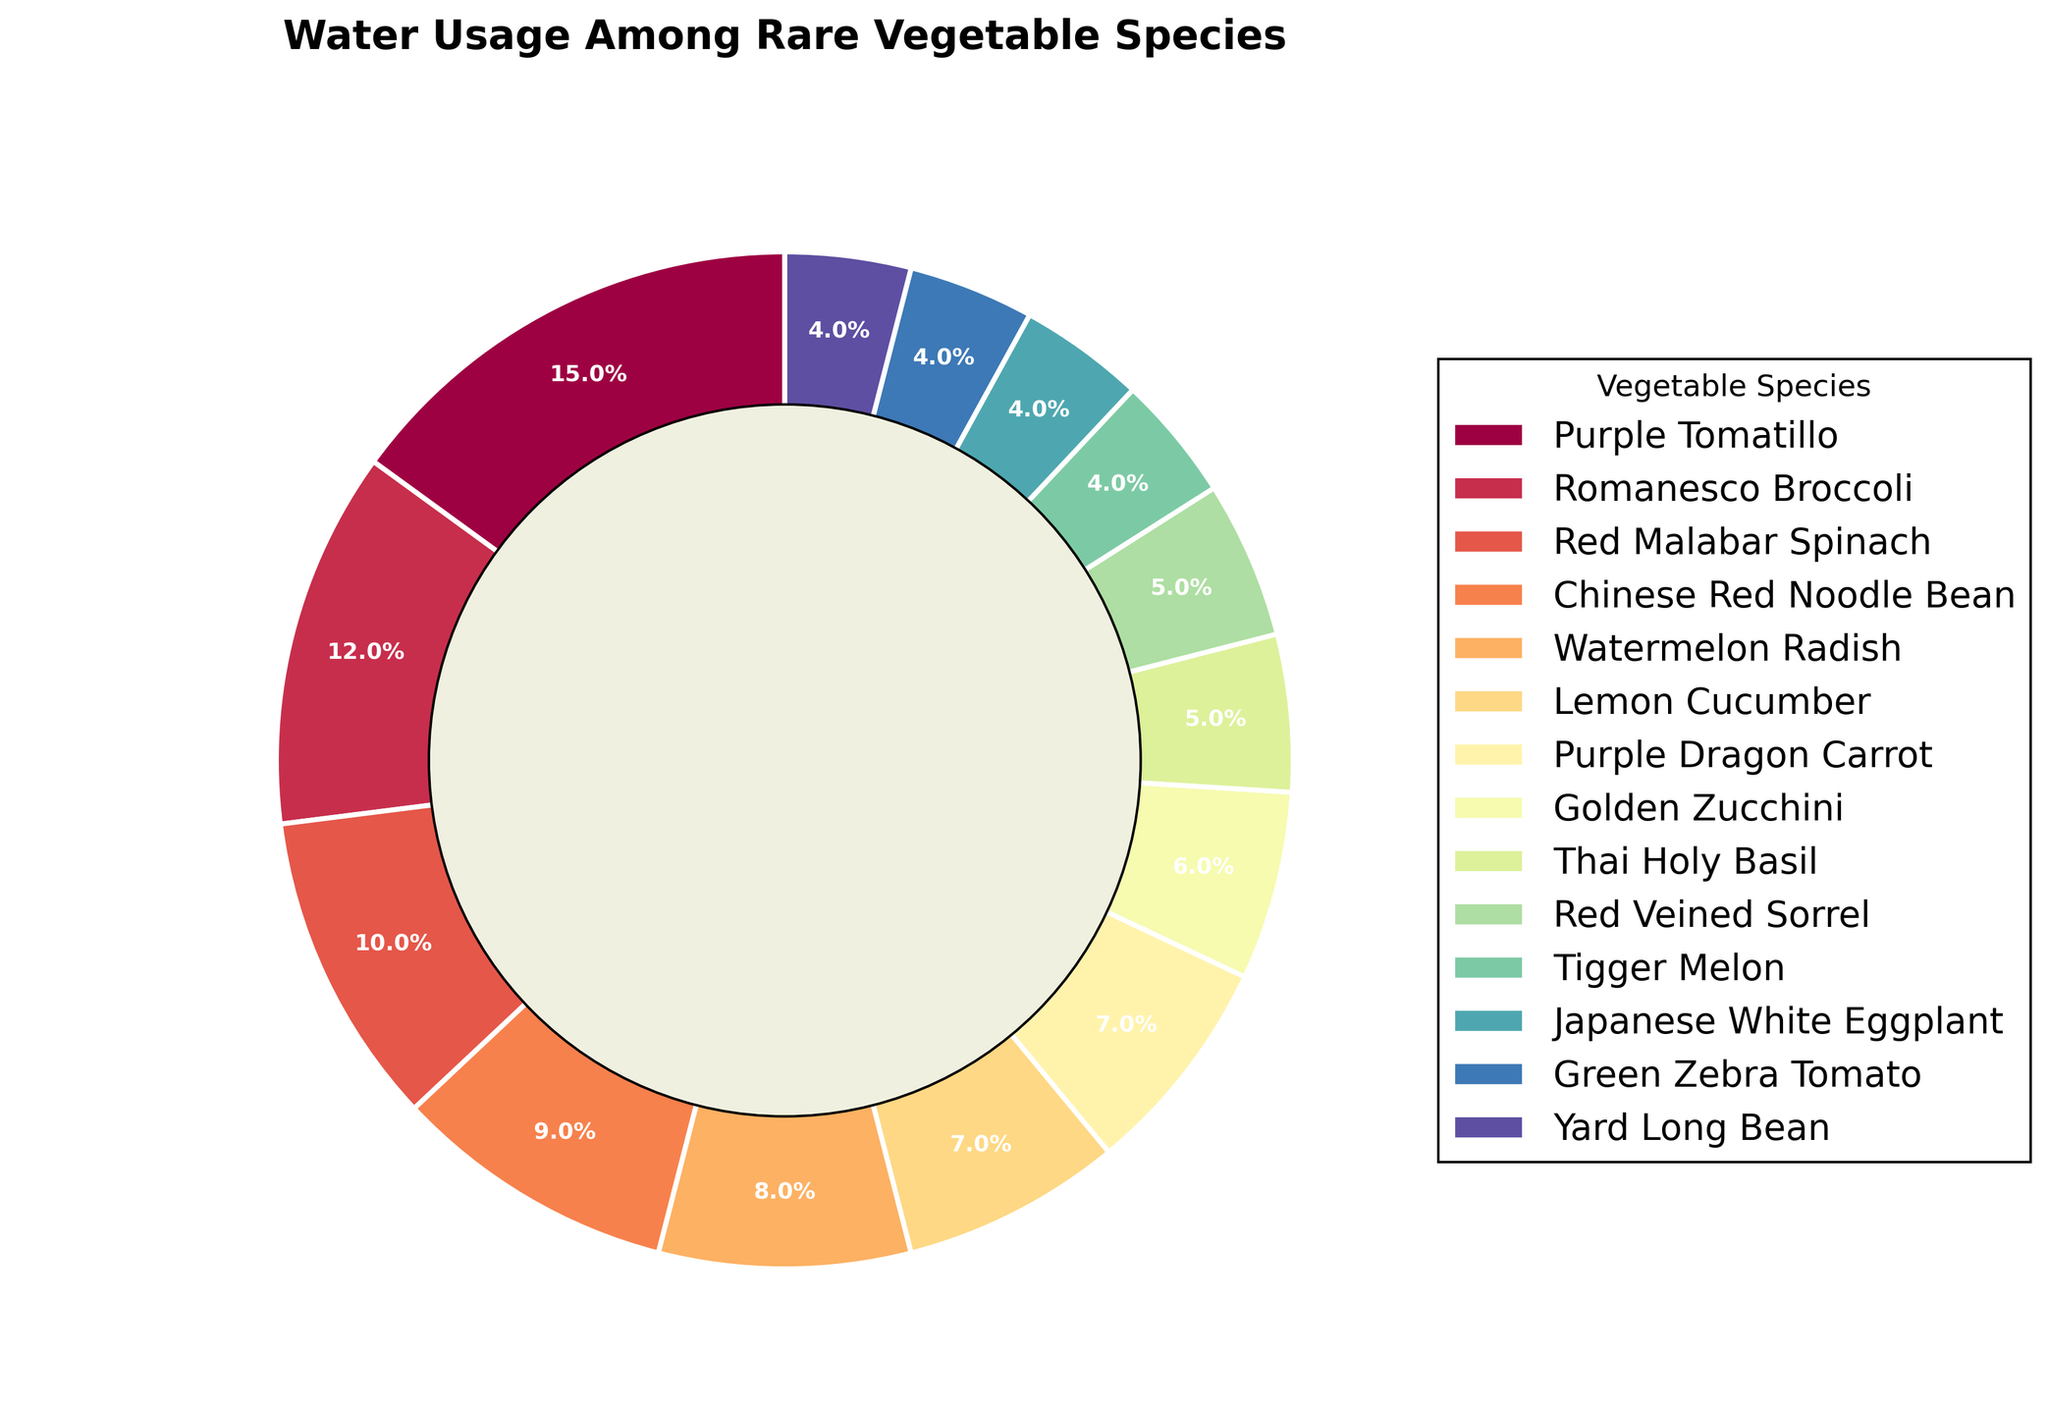1. Which vegetable species has the highest water usage? Purple Tomatillo has the highest water usage as it takes up 15% of the total water allocation, which is the largest segment on the pie chart.
Answer: Purple Tomatillo 2. Which vegetable species requires less water: Thai Holy Basil or Purple Dragon Carrot? Comparing the slices, Thai Holy Basil takes up 5% and Purple Dragon Carrot takes up 7%. Therefore, Thai Holy Basil requires less water.
Answer: Thai Holy Basil 3. What is the combined water usage percentage of Red Malabar Spinach and Chinese Red Noodle Bean? Red Malabar Spinach uses 10% and Chinese Red Noodle Bean uses 9%. Adding these percentages together, 10% + 9%, gives a combined water usage of 19%.
Answer: 19% 4. Are there any vegetable species with equal water usage? If so, list them. By looking at the pie chart, Lemon Cucumber and Purple Dragon Carrot each use 7%, while Red Veined Sorrel and Thai Holy Basil each use 5%, and Tigger Melon, Japanese White Eggplant, Green Zebra Tomato, and Yard Long Bean each use 4%.
Answer: Lemon Cucumber and Purple Dragon Carrot, Red Veined Sorrel and Thai Holy Basil, Tigger Melon, Japanese White Eggplant, Green Zebra Tomato, Yard Long Bean 5. Which species uses more water: Golden Zucchini or Watermelon Radish? Golden Zucchini takes up 6% of the water allocation while Watermelon Radish takes 8%. Therefore, Watermelon Radish uses more water.
Answer: Watermelon Radish 6. Rank the top three species by water usage. By looking at the sizes of the segments, the top three species by water usage are Purple Tomatillo (15%), Romanesco Broccoli (12%), and Red Malabar Spinach (10%).
Answer: Purple Tomatillo, Romanesco Broccoli, Red Malabar Spinach 7. What is the difference in water usage between Red Veined Sorrel and Yard Long Bean? Red Veined Sorrel uses 5% while Yard Long Bean uses 4%. Subtracting the percentages, 5% - 4%, gives a difference of 1%.
Answer: 1% 8. What is the average water usage of the four species with the lowest water usage? The lowest water-usage species are Tigger Melon (4%), Japanese White Eggplant (4%), Green Zebra Tomato (4%), and Yard Long Bean (4%). Summing these, 4% + 4% + 4% + 4% = 16%, and dividing by 4, the average is 16% / 4 = 4%.
Answer: 4% 9. Which species requires three times as much water as Thai Holy Basil? Thai Holy Basil uses 5%. Three times this amount is 5% * 3 = 15%. Purple Tomatillo, which uses 15%, requires three times as much water as Thai Holy Basil.
Answer: Purple Tomatillo 10. How much more water does Romanesco Broccoli use compared to Lemon Cucumber? Romanesco Broccoli uses 12% and Lemon Cucumber uses 7%. The difference between them is 12% - 7% = 5%.
Answer: 5% 